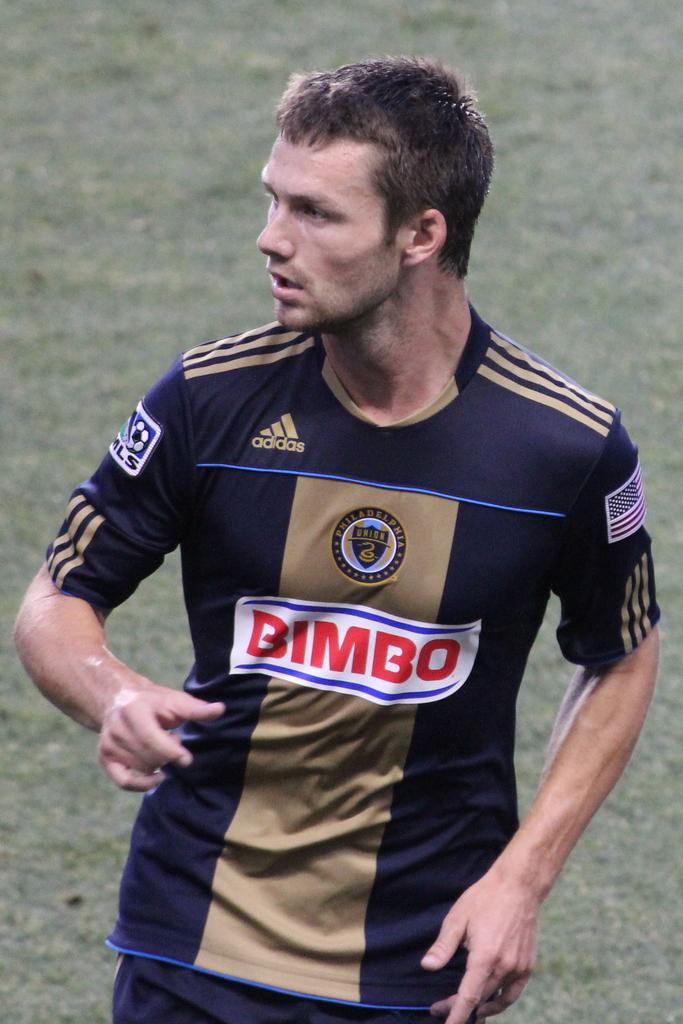What brand of jersey is this?
Keep it short and to the point. Adidas. 